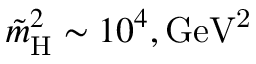Convert formula to latex. <formula><loc_0><loc_0><loc_500><loc_500>\tilde { m } _ { H } ^ { 2 } \sim 1 0 ^ { 4 } , G e V ^ { 2 }</formula> 